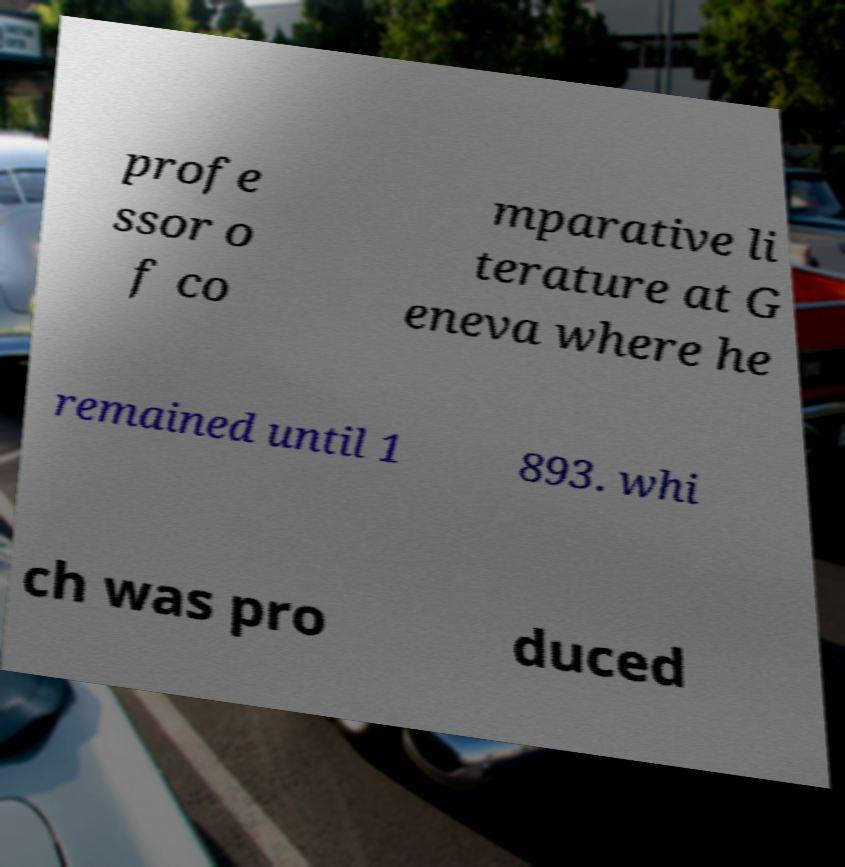Please identify and transcribe the text found in this image. profe ssor o f co mparative li terature at G eneva where he remained until 1 893. whi ch was pro duced 